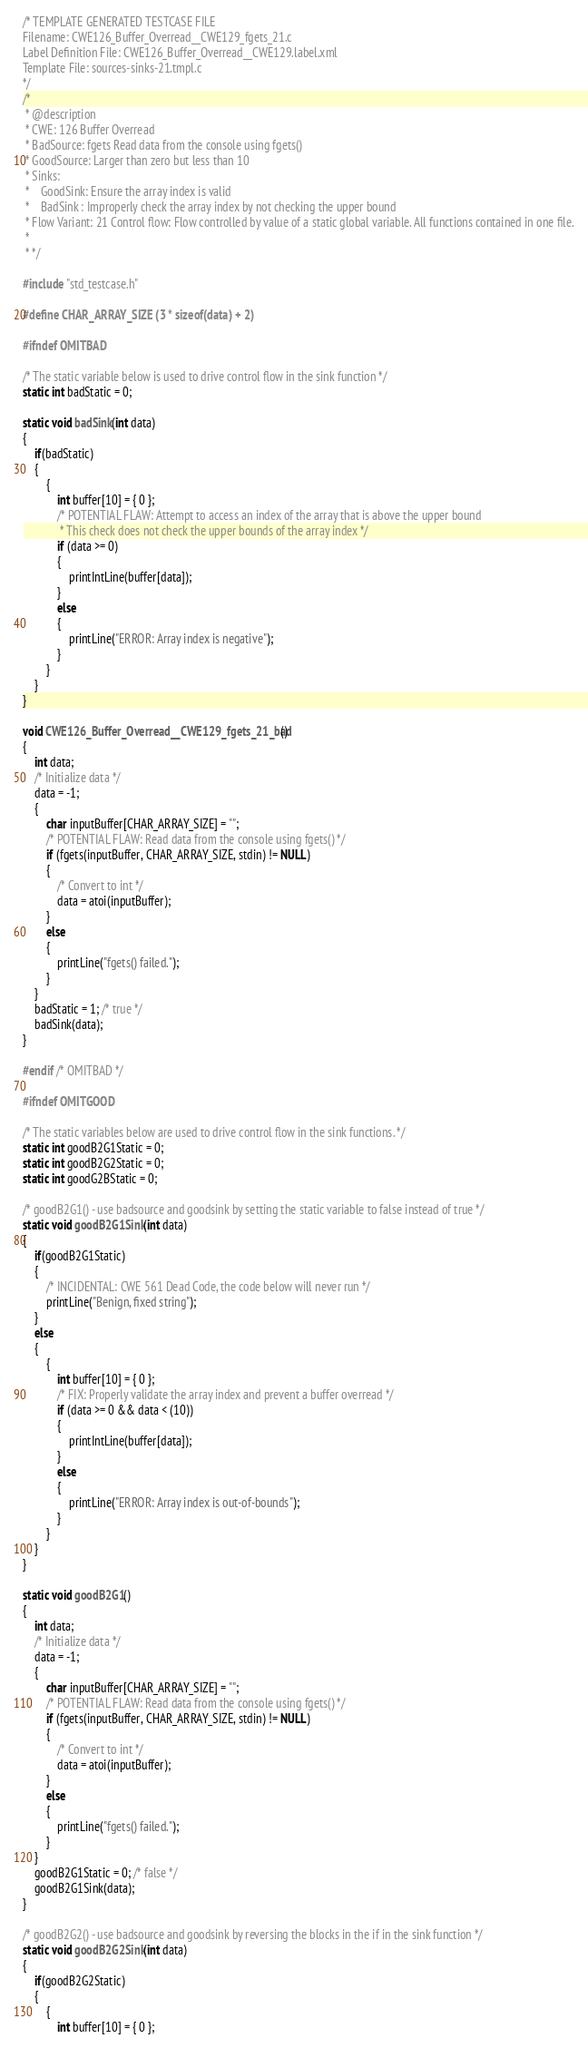<code> <loc_0><loc_0><loc_500><loc_500><_C_>/* TEMPLATE GENERATED TESTCASE FILE
Filename: CWE126_Buffer_Overread__CWE129_fgets_21.c
Label Definition File: CWE126_Buffer_Overread__CWE129.label.xml
Template File: sources-sinks-21.tmpl.c
*/
/*
 * @description
 * CWE: 126 Buffer Overread
 * BadSource: fgets Read data from the console using fgets()
 * GoodSource: Larger than zero but less than 10
 * Sinks:
 *    GoodSink: Ensure the array index is valid
 *    BadSink : Improperly check the array index by not checking the upper bound
 * Flow Variant: 21 Control flow: Flow controlled by value of a static global variable. All functions contained in one file.
 *
 * */

#include "std_testcase.h"

#define CHAR_ARRAY_SIZE (3 * sizeof(data) + 2)

#ifndef OMITBAD

/* The static variable below is used to drive control flow in the sink function */
static int badStatic = 0;

static void badSink(int data)
{
    if(badStatic)
    {
        {
            int buffer[10] = { 0 };
            /* POTENTIAL FLAW: Attempt to access an index of the array that is above the upper bound
             * This check does not check the upper bounds of the array index */
            if (data >= 0)
            {
                printIntLine(buffer[data]);
            }
            else
            {
                printLine("ERROR: Array index is negative");
            }
        }
    }
}

void CWE126_Buffer_Overread__CWE129_fgets_21_bad()
{
    int data;
    /* Initialize data */
    data = -1;
    {
        char inputBuffer[CHAR_ARRAY_SIZE] = "";
        /* POTENTIAL FLAW: Read data from the console using fgets() */
        if (fgets(inputBuffer, CHAR_ARRAY_SIZE, stdin) != NULL)
        {
            /* Convert to int */
            data = atoi(inputBuffer);
        }
        else
        {
            printLine("fgets() failed.");
        }
    }
    badStatic = 1; /* true */
    badSink(data);
}

#endif /* OMITBAD */

#ifndef OMITGOOD

/* The static variables below are used to drive control flow in the sink functions. */
static int goodB2G1Static = 0;
static int goodB2G2Static = 0;
static int goodG2BStatic = 0;

/* goodB2G1() - use badsource and goodsink by setting the static variable to false instead of true */
static void goodB2G1Sink(int data)
{
    if(goodB2G1Static)
    {
        /* INCIDENTAL: CWE 561 Dead Code, the code below will never run */
        printLine("Benign, fixed string");
    }
    else
    {
        {
            int buffer[10] = { 0 };
            /* FIX: Properly validate the array index and prevent a buffer overread */
            if (data >= 0 && data < (10))
            {
                printIntLine(buffer[data]);
            }
            else
            {
                printLine("ERROR: Array index is out-of-bounds");
            }
        }
    }
}

static void goodB2G1()
{
    int data;
    /* Initialize data */
    data = -1;
    {
        char inputBuffer[CHAR_ARRAY_SIZE] = "";
        /* POTENTIAL FLAW: Read data from the console using fgets() */
        if (fgets(inputBuffer, CHAR_ARRAY_SIZE, stdin) != NULL)
        {
            /* Convert to int */
            data = atoi(inputBuffer);
        }
        else
        {
            printLine("fgets() failed.");
        }
    }
    goodB2G1Static = 0; /* false */
    goodB2G1Sink(data);
}

/* goodB2G2() - use badsource and goodsink by reversing the blocks in the if in the sink function */
static void goodB2G2Sink(int data)
{
    if(goodB2G2Static)
    {
        {
            int buffer[10] = { 0 };</code> 